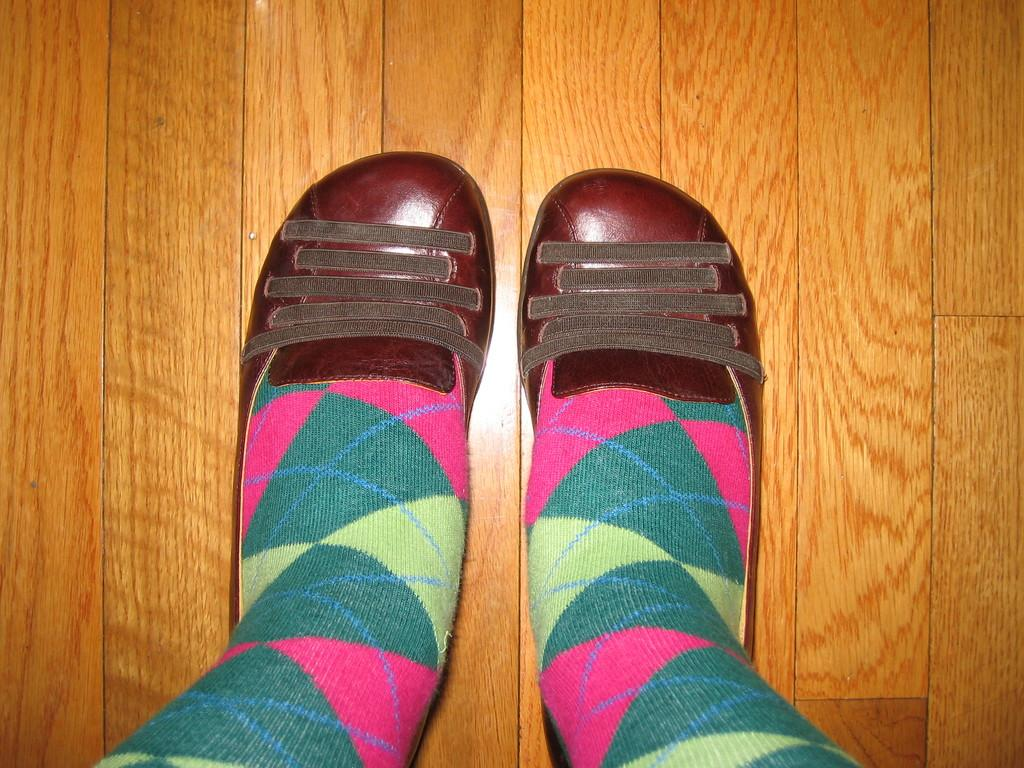What body parts can be seen in the image? Legs are visible in the image. What are the legs wearing? There are shoes visible in the image. What type of object can be seen in the image? There is a wooden object in the image. Where might this image have been taken? The image is likely taken in a room, as it is an indoor setting. What verse is the person reading from in the image? There is no person or reading material visible in the image, so it is not possible to determine what verse might be read. 